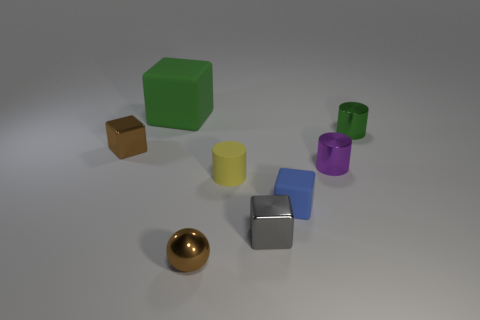Is the green thing that is behind the green metal thing made of the same material as the tiny block behind the blue thing? It appears that the large green object and the tiny block share a similar visual texture that suggests they might be made from the same plastic material. However, without more context or information about the objects' composition, we can't conclusively determine if they are indeed made from the identical material. 